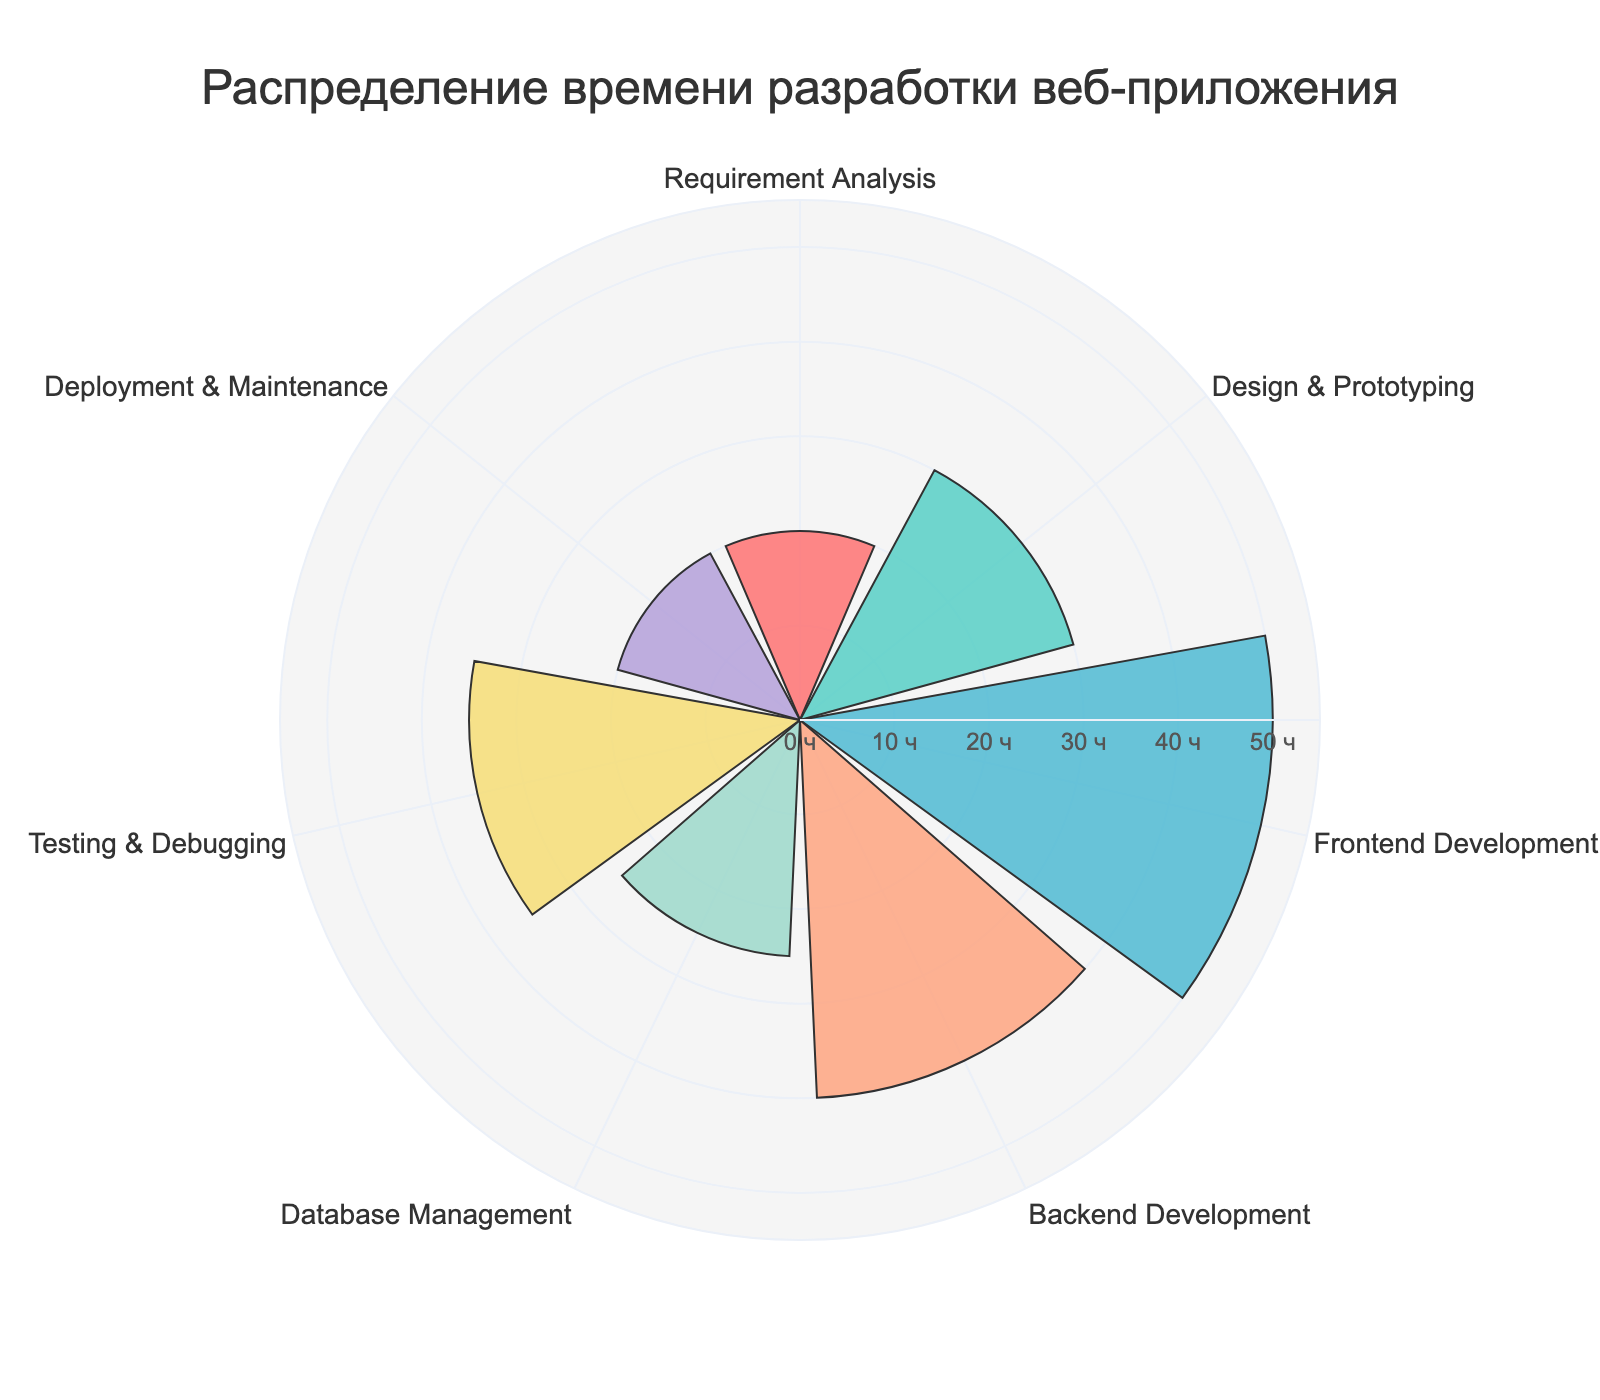What is the title of the figure? The title of the figure is displayed prominently at the top, typically in a larger and bold font to grab attention.
Answer: "Распределение времени разработки веб-приложения" Which category has the maximum development time? By inspecting the lengths of the radial bars, the "Frontend Development" category has the longest bar, indicating the highest value.
Answer: Frontend Development How many hours are allocated to Testing & Debugging? The radial bar corresponding to "Testing & Debugging" reaches the value of 35 hours as marked on the radial axis.
Answer: 35 What is the total development time for Requirement Analysis, Design & Prototyping, and Database Management? Adding the values of these stages: 20 (Requirement Analysis) + 30 (Design & Prototyping) + 25 (Database Management) = 75 hours.
Answer: 75 How does the development time for Backend Development compare to Frontend Development? Frontend Development has 50 hours, while Backend Development has 40 hours. Therefore, Frontend Development has 10 more hours compared to Backend Development.
Answer: 10 more hours Which stages have an equal amount of development time allocated? By matching the radial bars, "Requirement Analysis" and "Deployment & Maintenance" both have 20 hours allocated.
Answer: Requirement Analysis and Deployment & Maintenance What is the average development time across all the categories? Add all values and divide by the number of categories: (20 + 30 + 50 + 40 + 25 + 35 + 20) / 7. This equals 220 / 7 ≈ 31.43 hours.
Answer: Approximately 31.43 hours Compare the total development time allocated to Design & Prototyping and Testing & Debugging. Which one has more and by how much? Design & Prototyping has 30 hours, while Testing & Debugging has 35 hours. The difference is 35 - 30 = 5 hours.
Answer: Testing & Debugging by 5 hours If the development time for Database Management increases by 10 hours, what would be its new value? The current time for Database Management is 25 hours. Adding 10 hours results in 25 + 10 = 35 hours.
Answer: 35 hours What percentage of the total development time is allocated to Backend Development? The total development time is 220 hours. The time for Backend Development is 40 hours. The percentage is (40 / 220) * 100 ≈ 18.18%.
Answer: Approximately 18.18% 